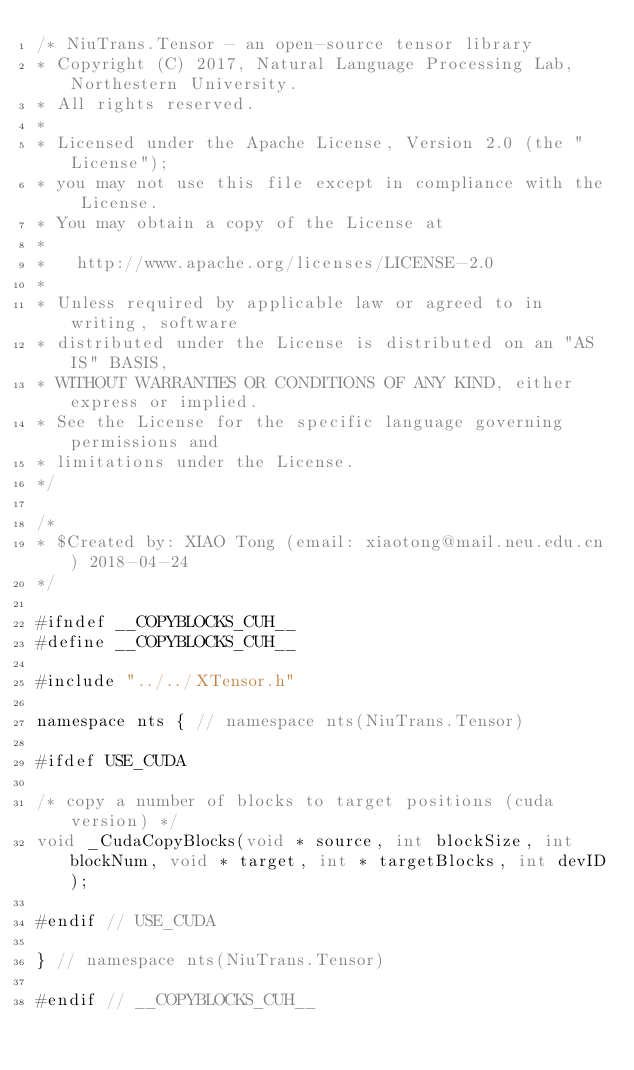Convert code to text. <code><loc_0><loc_0><loc_500><loc_500><_Cuda_>/* NiuTrans.Tensor - an open-source tensor library
* Copyright (C) 2017, Natural Language Processing Lab, Northestern University.
* All rights reserved.
*
* Licensed under the Apache License, Version 2.0 (the "License");
* you may not use this file except in compliance with the License.
* You may obtain a copy of the License at
*
*   http://www.apache.org/licenses/LICENSE-2.0
*
* Unless required by applicable law or agreed to in writing, software
* distributed under the License is distributed on an "AS IS" BASIS,
* WITHOUT WARRANTIES OR CONDITIONS OF ANY KIND, either express or implied.
* See the License for the specific language governing permissions and
* limitations under the License.
*/

/*
* $Created by: XIAO Tong (email: xiaotong@mail.neu.edu.cn) 2018-04-24
*/

#ifndef __COPYBLOCKS_CUH__
#define __COPYBLOCKS_CUH__

#include "../../XTensor.h"

namespace nts { // namespace nts(NiuTrans.Tensor)

#ifdef USE_CUDA

/* copy a number of blocks to target positions (cuda version) */
void _CudaCopyBlocks(void * source, int blockSize, int blockNum, void * target, int * targetBlocks, int devID);

#endif // USE_CUDA

} // namespace nts(NiuTrans.Tensor)

#endif // __COPYBLOCKS_CUH__
</code> 